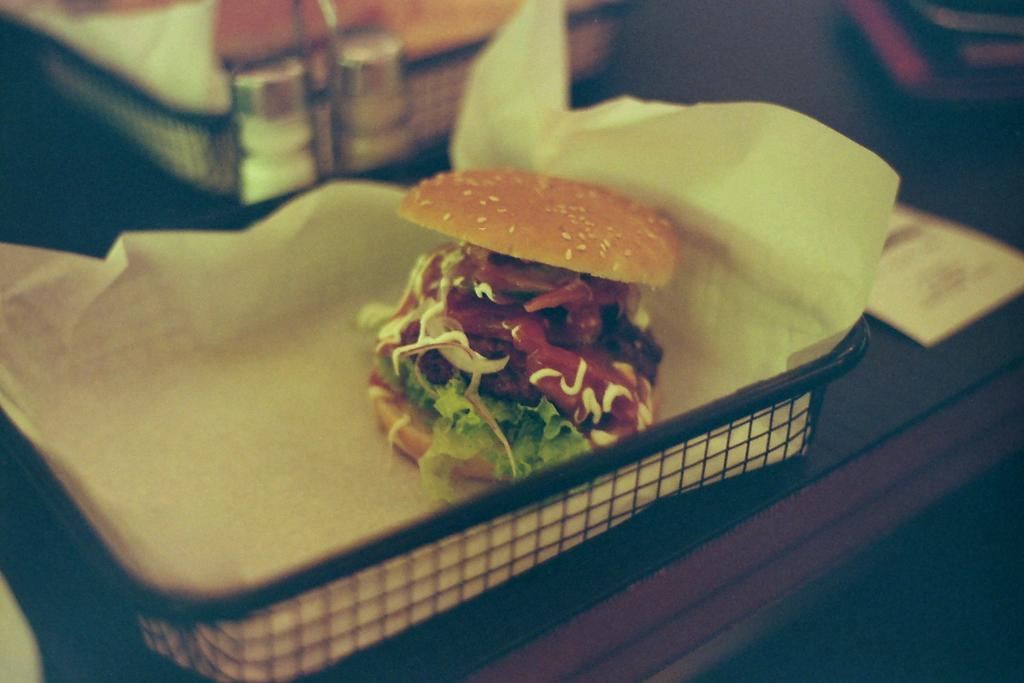What is present on the tray in the image? There is a paper and a bun in the tray. What type of object is the tray placed on? The tray is on an object, but the specific type of object is not mentioned in the facts. Are there any other food items in the tray? Yes, there are food items in the tray. What can be seen in the background of the image? There is a tree visible in the image, and there are other things in the background. How many pigs are visible in the image? There are no pigs present in the image. What type of land can be seen in the image? The image does not show any specific type of land; it only shows a tray with food items and a tree in the background. 